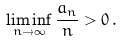<formula> <loc_0><loc_0><loc_500><loc_500>\liminf _ { n \to \infty } \frac { a _ { n } } { n } > 0 \, .</formula> 